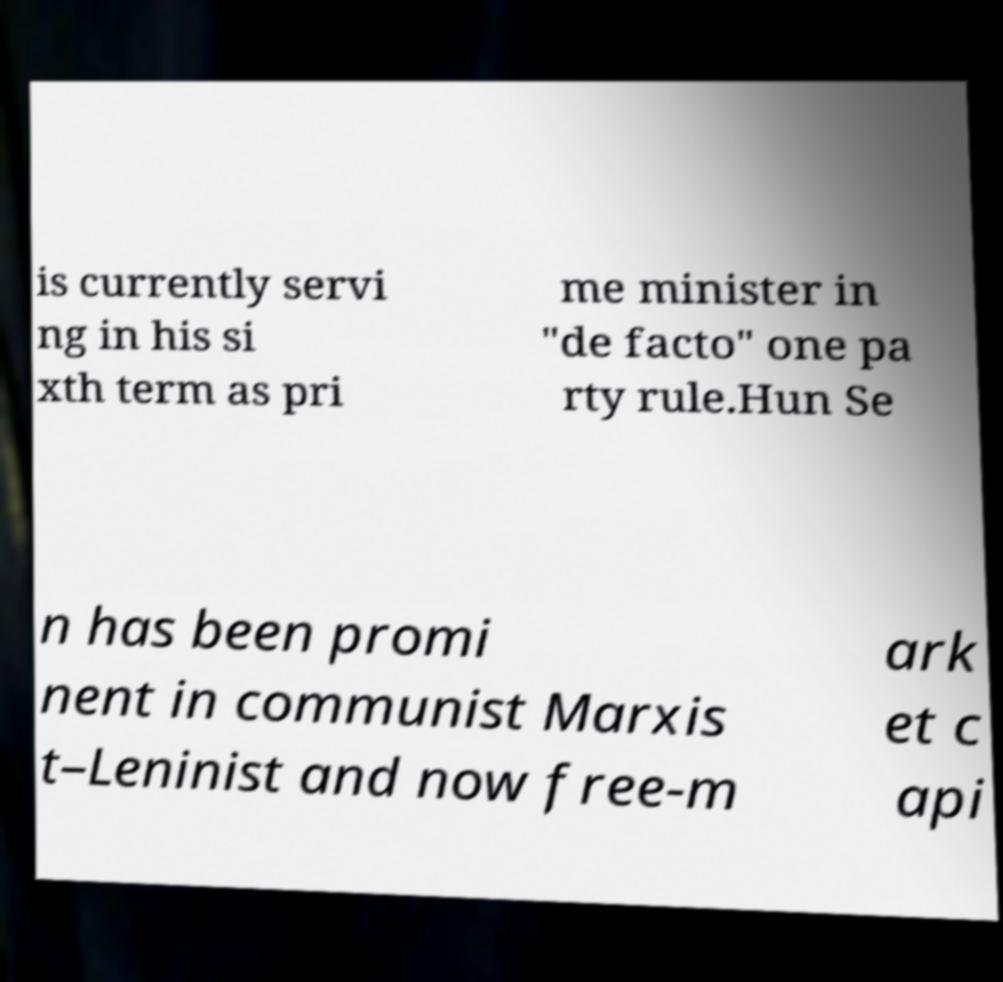What messages or text are displayed in this image? I need them in a readable, typed format. is currently servi ng in his si xth term as pri me minister in "de facto" one pa rty rule.Hun Se n has been promi nent in communist Marxis t–Leninist and now free-m ark et c api 